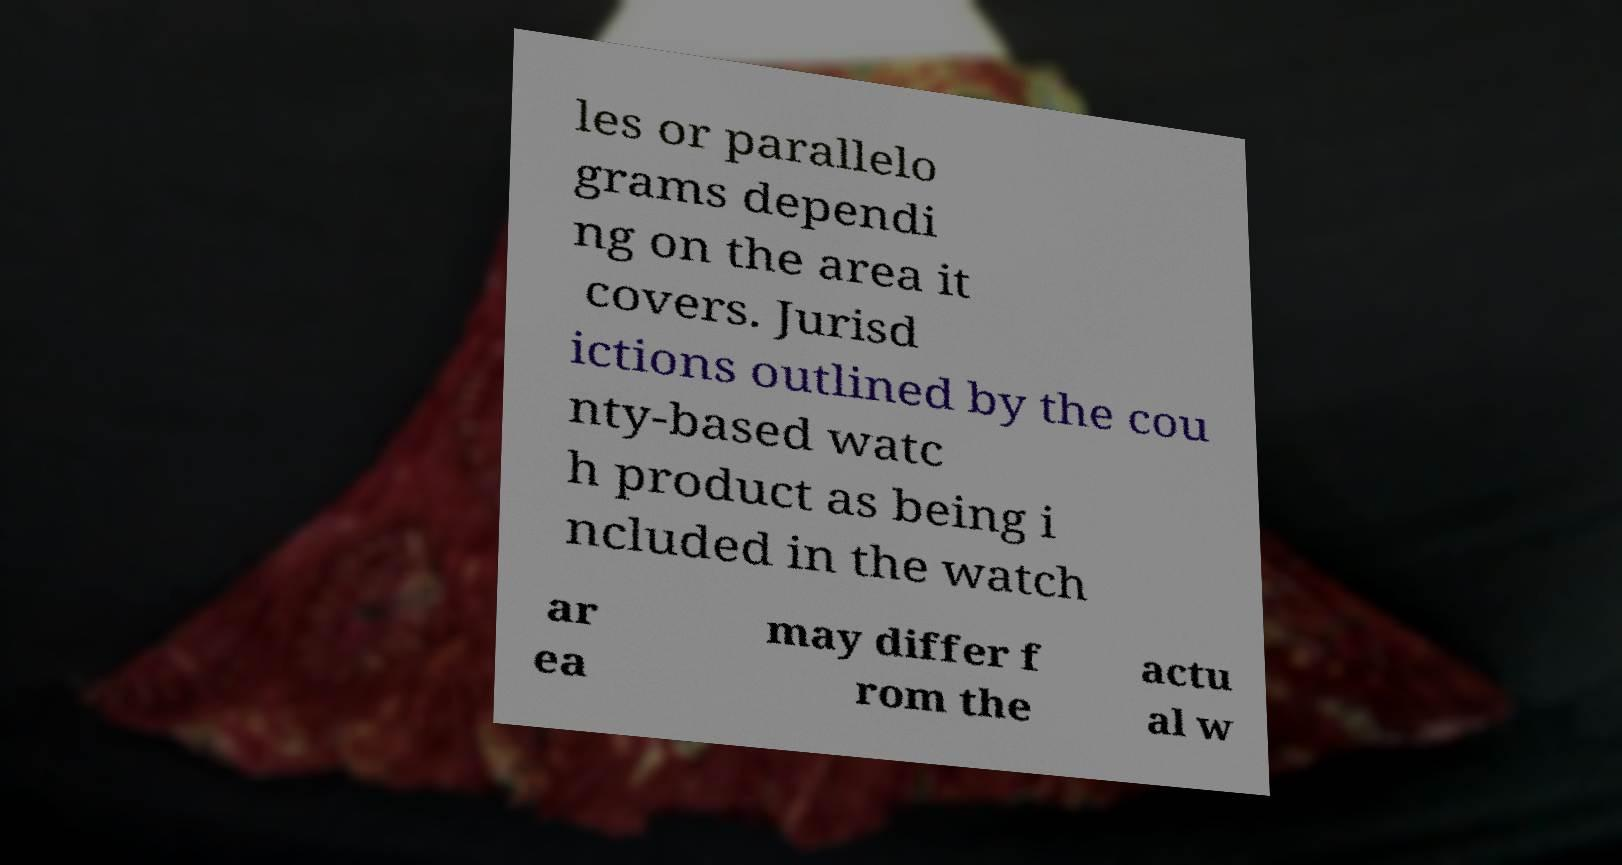Could you assist in decoding the text presented in this image and type it out clearly? les or parallelo grams dependi ng on the area it covers. Jurisd ictions outlined by the cou nty-based watc h product as being i ncluded in the watch ar ea may differ f rom the actu al w 